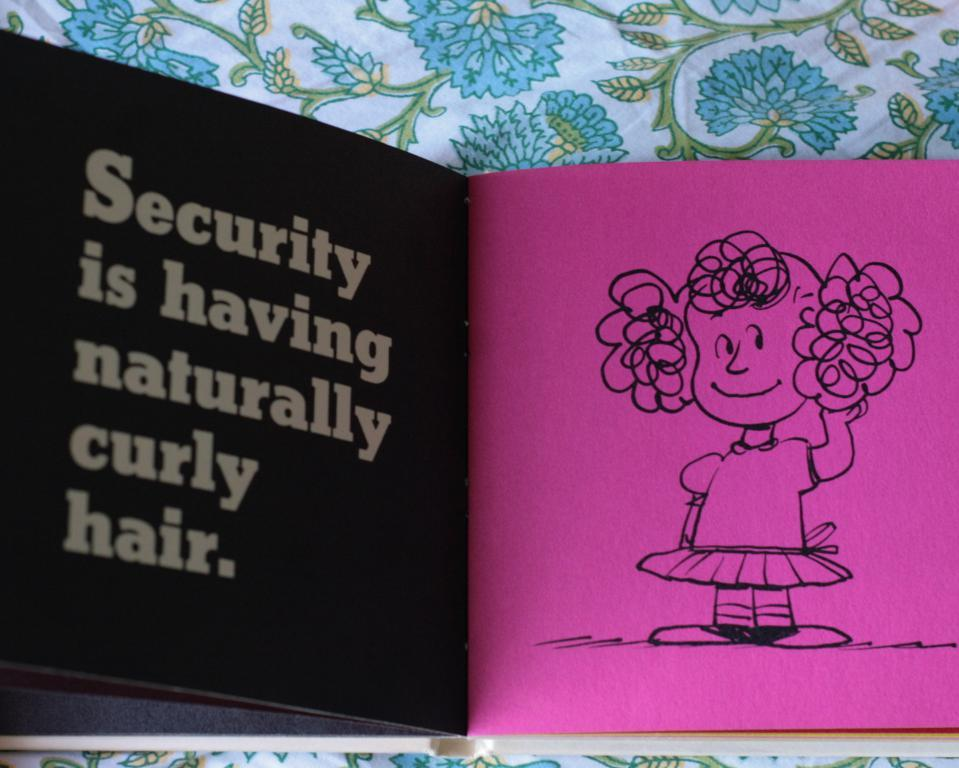What is the main object in the image? There is a book in the image. What else can be seen on pink paper in the image? There is a drawing and writing on the pink paper. What type of material is visible in the image? There is cloth visible in the image. What type of beef is being served in the image? There is no beef present in the image. What time of day is it in the image? The time of day is not mentioned or depicted in the image. 